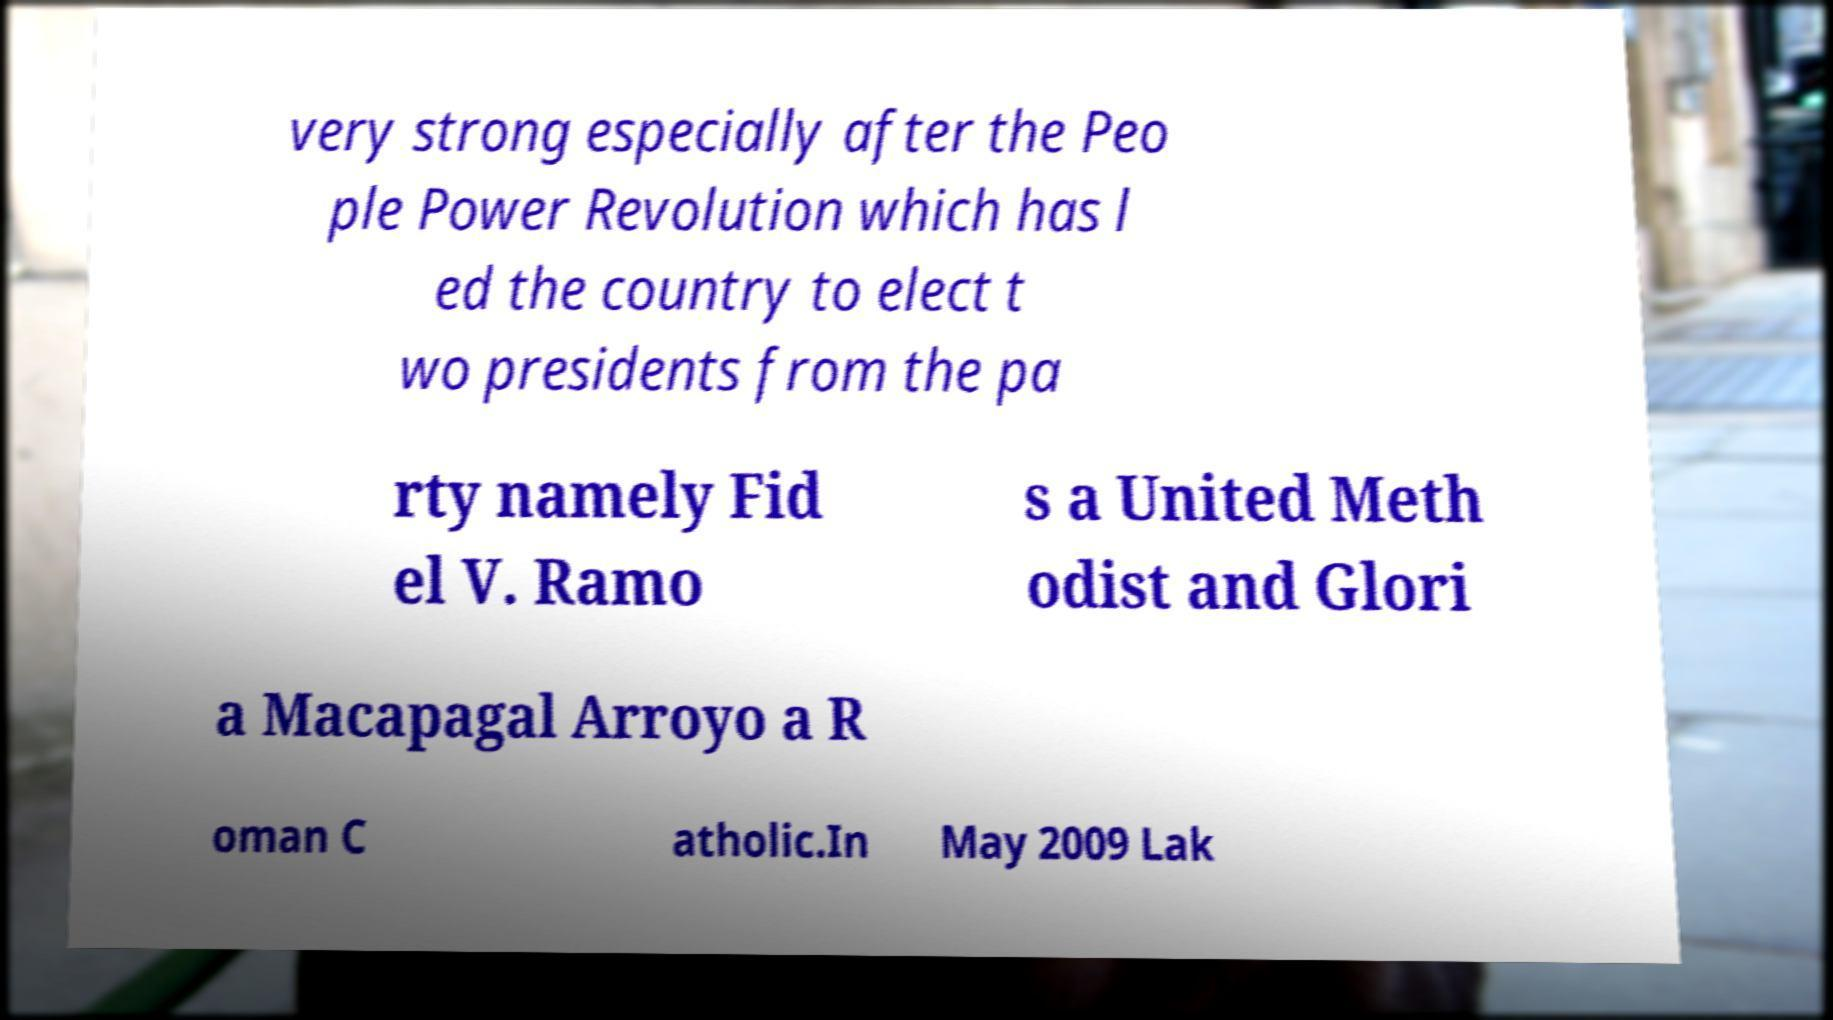Could you assist in decoding the text presented in this image and type it out clearly? very strong especially after the Peo ple Power Revolution which has l ed the country to elect t wo presidents from the pa rty namely Fid el V. Ramo s a United Meth odist and Glori a Macapagal Arroyo a R oman C atholic.In May 2009 Lak 